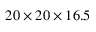Convert formula to latex. <formula><loc_0><loc_0><loc_500><loc_500>2 0 \times 2 0 \times 1 6 . 5</formula> 